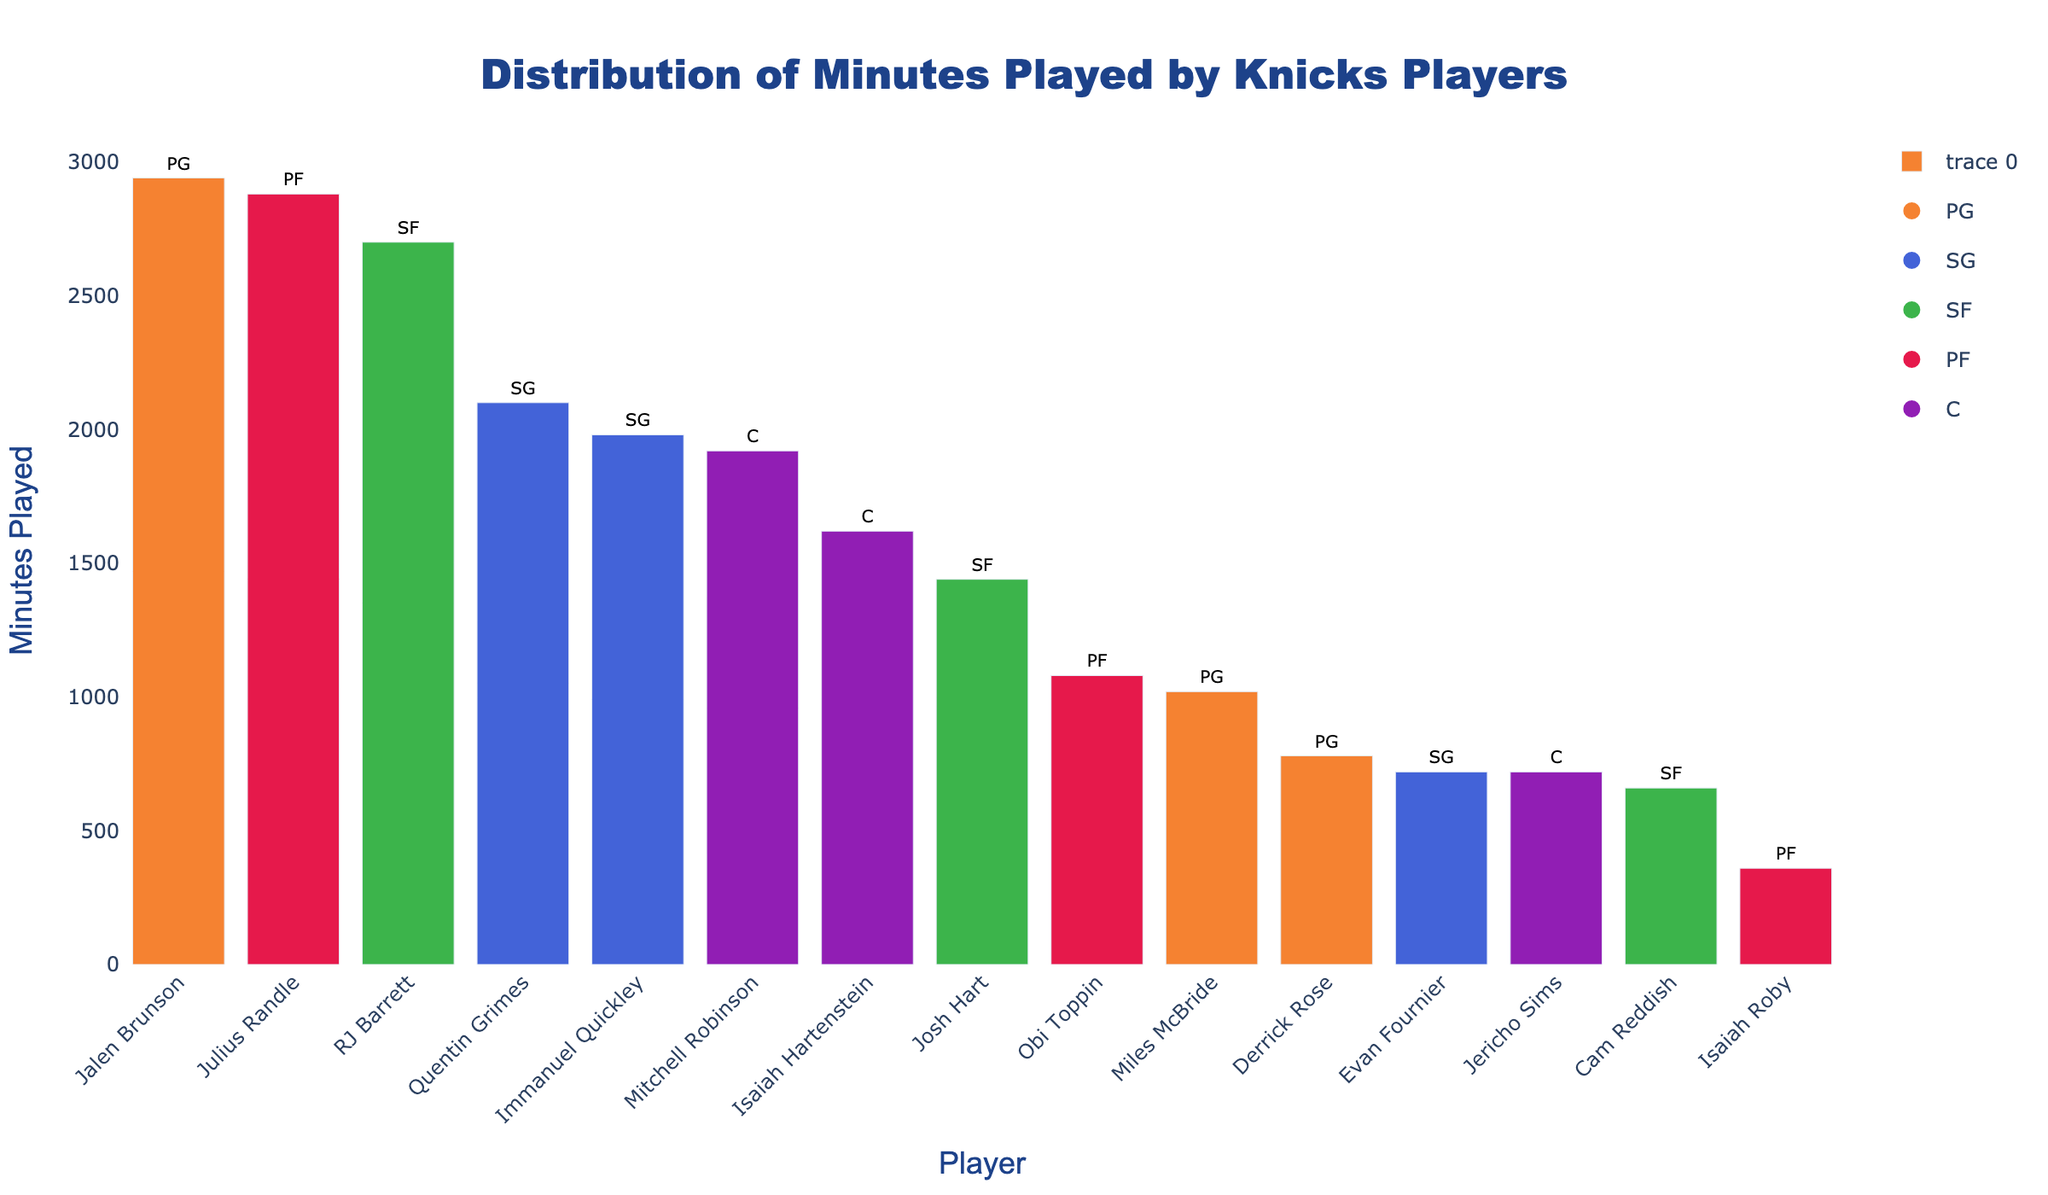How many minutes did the top SF player play? RJ Barrett is the top SF player in the chart and his minutes are shown at 2700.
Answer: 2700 Which position has the player with the most minutes? The player with the most minutes is Jalen Brunson, who plays as a PG.
Answer: PG Compare the total minutes played by all PGs to all SGs. Which is higher and by how much? The total minutes for PGs are (2940 + 1020 + 780) = 4740. The total minutes for SGs are (2100 + 1980 + 720) = 4800. SGs are higher by 60 minutes.
Answer: SGs, by 60 minutes What is the color representing the PF position in the plot? The PF position is represented by red-colored bars in the plot.
Answer: Red How many players played between 1000 and 2000 minutes? Referencing each bar's height, players are: Miles McBride, Derrick Rose, Quentin Grimes, Immanuel Quickley, Josh Hart, Obi Toppin, Mitchell Robinson, Isaiah Hartenstein. That's 8 players.
Answer: 8 What is the difference in minutes between the top C player and the top PG player? The top C player (Mitchell Robinson) played 1920 minutes, the top PG player (Jalen Brunson) played 2940 minutes. Difference is 2940 - 1920 = 1020 minutes.
Answer: 1020 minutes What is the average minutes played by players in the PF position? Total minutes for PFs are (2880 + 1080 + 360) = 4320. There are 3 PF players, so the average is 4320 / 3 = 1440 minutes.
Answer: 1440 minutes Who played the least minutes in the PF position and how many? Isaiah Roby played the least minutes in the PF position with 360 minutes.
Answer: Isaiah Roby, 360 Which SF player has the least minutes and what proportion of RJ Barrett's minutes have they played? Cam Reddish has the least minutes (660) among SFs. RJ Barrett played 2700 minutes, so proportion is 660 / 2700 = 0.244 (or 24.4%).
Answer: Cam Reddish, 24.4% 